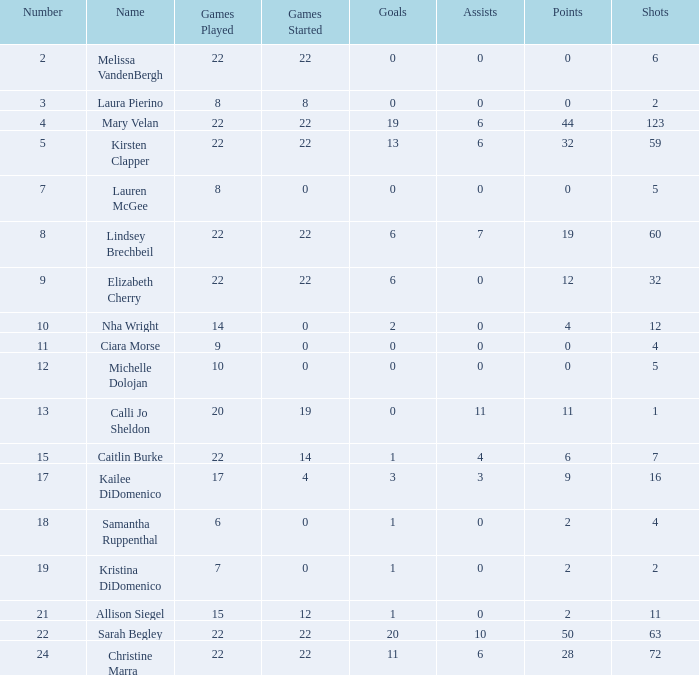In how many different game categories has lauren mcgee participated? 1.0. 